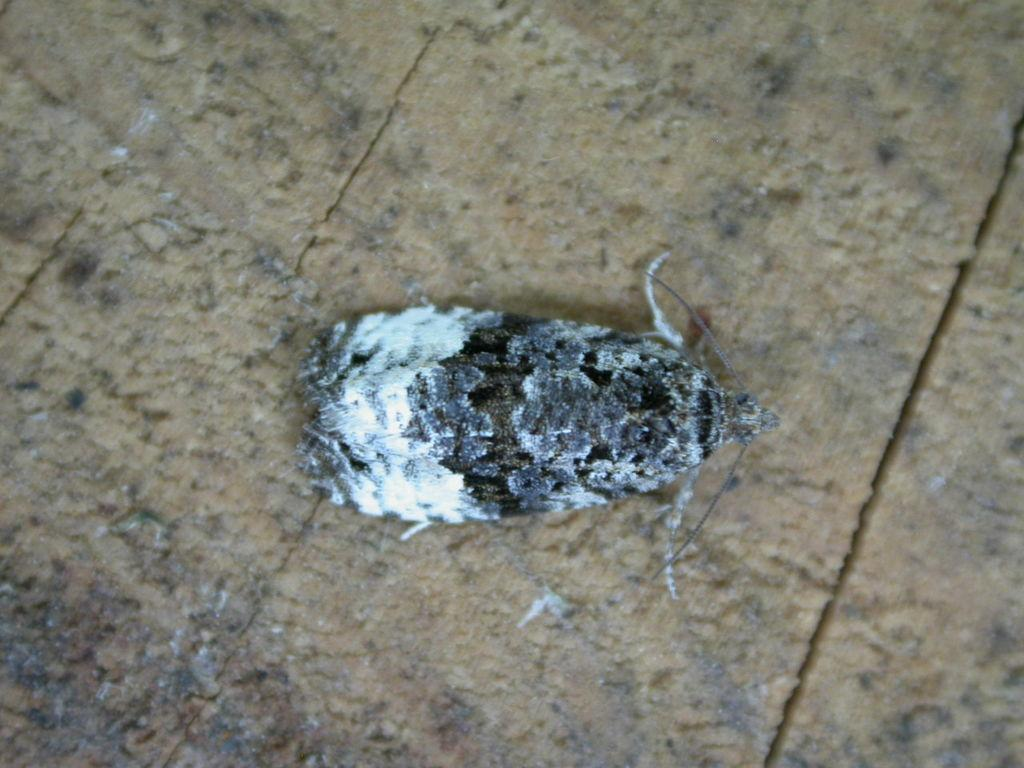Where was the image taken? The image was taken outdoors. What can be seen at the bottom of the image? There is a floor at the bottom of the image. What is present on the floor in the middle of the image? There is a fly on the floor in the middle of the image. What type of parcel is being delivered on the stone table in the image? There is no parcel or stone table present in the image; it only features a fly on the floor. 